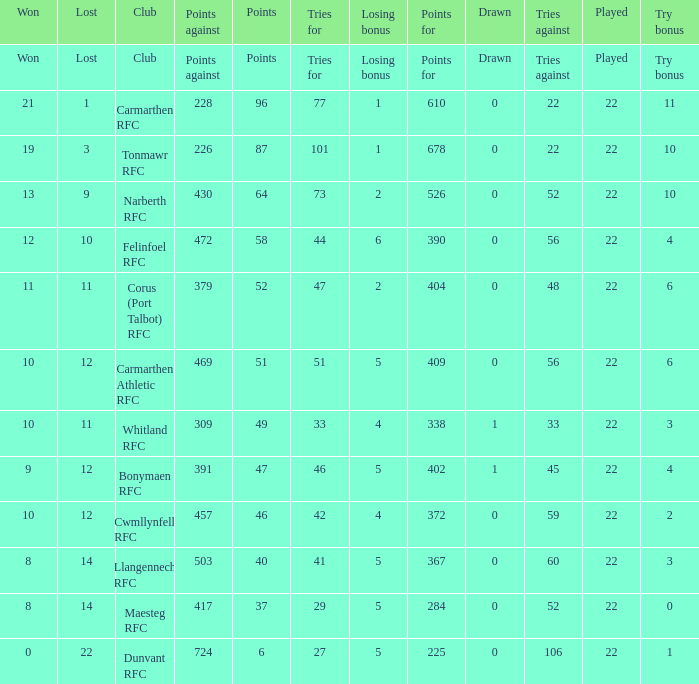Name the points against for 51 points 469.0. 